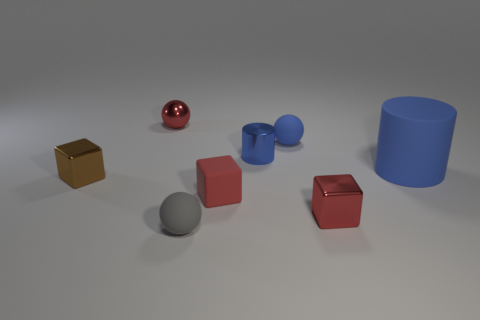Add 1 big gray shiny blocks. How many objects exist? 9 Subtract all cylinders. How many objects are left? 6 Add 5 large blue cylinders. How many large blue cylinders exist? 6 Subtract 0 gray cubes. How many objects are left? 8 Subtract all blue shiny cylinders. Subtract all big blue objects. How many objects are left? 6 Add 7 blue objects. How many blue objects are left? 10 